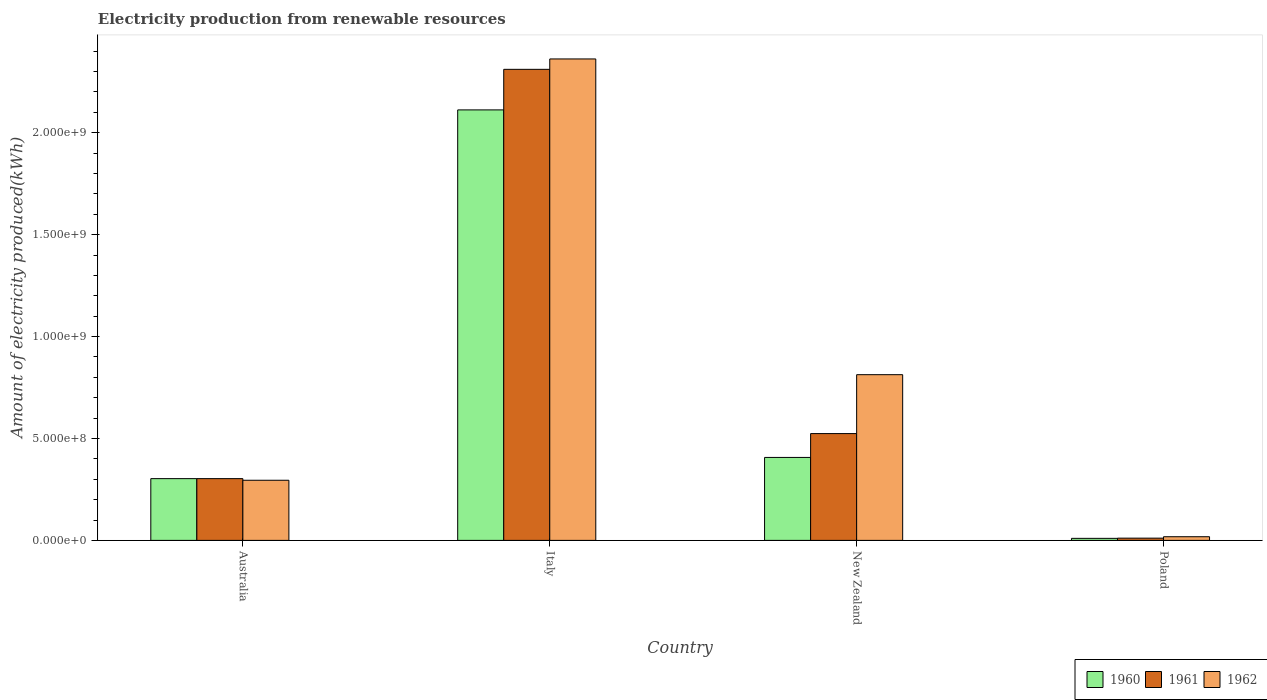How many different coloured bars are there?
Give a very brief answer. 3. How many groups of bars are there?
Keep it short and to the point. 4. Are the number of bars on each tick of the X-axis equal?
Provide a succinct answer. Yes. How many bars are there on the 4th tick from the left?
Make the answer very short. 3. How many bars are there on the 2nd tick from the right?
Keep it short and to the point. 3. What is the amount of electricity produced in 1961 in Poland?
Give a very brief answer. 1.10e+07. Across all countries, what is the maximum amount of electricity produced in 1961?
Provide a succinct answer. 2.31e+09. Across all countries, what is the minimum amount of electricity produced in 1962?
Offer a terse response. 1.80e+07. In which country was the amount of electricity produced in 1961 maximum?
Your response must be concise. Italy. In which country was the amount of electricity produced in 1960 minimum?
Ensure brevity in your answer.  Poland. What is the total amount of electricity produced in 1960 in the graph?
Provide a short and direct response. 2.83e+09. What is the difference between the amount of electricity produced in 1960 in Australia and that in Poland?
Make the answer very short. 2.93e+08. What is the difference between the amount of electricity produced in 1962 in Poland and the amount of electricity produced in 1961 in Italy?
Provide a succinct answer. -2.29e+09. What is the average amount of electricity produced in 1962 per country?
Your answer should be very brief. 8.72e+08. What is the difference between the amount of electricity produced of/in 1961 and amount of electricity produced of/in 1962 in New Zealand?
Offer a terse response. -2.89e+08. In how many countries, is the amount of electricity produced in 1961 greater than 300000000 kWh?
Make the answer very short. 3. What is the ratio of the amount of electricity produced in 1960 in New Zealand to that in Poland?
Offer a terse response. 40.7. Is the amount of electricity produced in 1961 in Australia less than that in Poland?
Your response must be concise. No. What is the difference between the highest and the second highest amount of electricity produced in 1960?
Your answer should be compact. 1.81e+09. What is the difference between the highest and the lowest amount of electricity produced in 1960?
Offer a terse response. 2.10e+09. In how many countries, is the amount of electricity produced in 1962 greater than the average amount of electricity produced in 1962 taken over all countries?
Give a very brief answer. 1. Is the sum of the amount of electricity produced in 1960 in Italy and Poland greater than the maximum amount of electricity produced in 1961 across all countries?
Offer a terse response. No. What does the 1st bar from the left in Australia represents?
Your response must be concise. 1960. Are all the bars in the graph horizontal?
Your answer should be compact. No. How many countries are there in the graph?
Your response must be concise. 4. What is the difference between two consecutive major ticks on the Y-axis?
Ensure brevity in your answer.  5.00e+08. Does the graph contain any zero values?
Provide a short and direct response. No. Does the graph contain grids?
Your answer should be very brief. No. How many legend labels are there?
Offer a very short reply. 3. How are the legend labels stacked?
Offer a terse response. Horizontal. What is the title of the graph?
Ensure brevity in your answer.  Electricity production from renewable resources. What is the label or title of the X-axis?
Provide a succinct answer. Country. What is the label or title of the Y-axis?
Offer a very short reply. Amount of electricity produced(kWh). What is the Amount of electricity produced(kWh) of 1960 in Australia?
Keep it short and to the point. 3.03e+08. What is the Amount of electricity produced(kWh) in 1961 in Australia?
Provide a short and direct response. 3.03e+08. What is the Amount of electricity produced(kWh) of 1962 in Australia?
Your answer should be very brief. 2.95e+08. What is the Amount of electricity produced(kWh) in 1960 in Italy?
Your response must be concise. 2.11e+09. What is the Amount of electricity produced(kWh) in 1961 in Italy?
Your answer should be compact. 2.31e+09. What is the Amount of electricity produced(kWh) in 1962 in Italy?
Provide a succinct answer. 2.36e+09. What is the Amount of electricity produced(kWh) in 1960 in New Zealand?
Provide a short and direct response. 4.07e+08. What is the Amount of electricity produced(kWh) in 1961 in New Zealand?
Your answer should be compact. 5.24e+08. What is the Amount of electricity produced(kWh) in 1962 in New Zealand?
Ensure brevity in your answer.  8.13e+08. What is the Amount of electricity produced(kWh) in 1961 in Poland?
Your response must be concise. 1.10e+07. What is the Amount of electricity produced(kWh) of 1962 in Poland?
Keep it short and to the point. 1.80e+07. Across all countries, what is the maximum Amount of electricity produced(kWh) in 1960?
Keep it short and to the point. 2.11e+09. Across all countries, what is the maximum Amount of electricity produced(kWh) of 1961?
Ensure brevity in your answer.  2.31e+09. Across all countries, what is the maximum Amount of electricity produced(kWh) in 1962?
Provide a short and direct response. 2.36e+09. Across all countries, what is the minimum Amount of electricity produced(kWh) in 1961?
Your answer should be very brief. 1.10e+07. Across all countries, what is the minimum Amount of electricity produced(kWh) of 1962?
Your answer should be compact. 1.80e+07. What is the total Amount of electricity produced(kWh) in 1960 in the graph?
Offer a very short reply. 2.83e+09. What is the total Amount of electricity produced(kWh) in 1961 in the graph?
Provide a succinct answer. 3.15e+09. What is the total Amount of electricity produced(kWh) in 1962 in the graph?
Provide a succinct answer. 3.49e+09. What is the difference between the Amount of electricity produced(kWh) of 1960 in Australia and that in Italy?
Offer a very short reply. -1.81e+09. What is the difference between the Amount of electricity produced(kWh) in 1961 in Australia and that in Italy?
Keep it short and to the point. -2.01e+09. What is the difference between the Amount of electricity produced(kWh) in 1962 in Australia and that in Italy?
Your answer should be compact. -2.07e+09. What is the difference between the Amount of electricity produced(kWh) in 1960 in Australia and that in New Zealand?
Offer a terse response. -1.04e+08. What is the difference between the Amount of electricity produced(kWh) in 1961 in Australia and that in New Zealand?
Make the answer very short. -2.21e+08. What is the difference between the Amount of electricity produced(kWh) in 1962 in Australia and that in New Zealand?
Your answer should be very brief. -5.18e+08. What is the difference between the Amount of electricity produced(kWh) of 1960 in Australia and that in Poland?
Provide a succinct answer. 2.93e+08. What is the difference between the Amount of electricity produced(kWh) of 1961 in Australia and that in Poland?
Provide a short and direct response. 2.92e+08. What is the difference between the Amount of electricity produced(kWh) in 1962 in Australia and that in Poland?
Offer a terse response. 2.77e+08. What is the difference between the Amount of electricity produced(kWh) of 1960 in Italy and that in New Zealand?
Make the answer very short. 1.70e+09. What is the difference between the Amount of electricity produced(kWh) in 1961 in Italy and that in New Zealand?
Keep it short and to the point. 1.79e+09. What is the difference between the Amount of electricity produced(kWh) in 1962 in Italy and that in New Zealand?
Give a very brief answer. 1.55e+09. What is the difference between the Amount of electricity produced(kWh) of 1960 in Italy and that in Poland?
Provide a succinct answer. 2.10e+09. What is the difference between the Amount of electricity produced(kWh) of 1961 in Italy and that in Poland?
Your answer should be very brief. 2.30e+09. What is the difference between the Amount of electricity produced(kWh) in 1962 in Italy and that in Poland?
Offer a terse response. 2.34e+09. What is the difference between the Amount of electricity produced(kWh) of 1960 in New Zealand and that in Poland?
Ensure brevity in your answer.  3.97e+08. What is the difference between the Amount of electricity produced(kWh) of 1961 in New Zealand and that in Poland?
Your answer should be very brief. 5.13e+08. What is the difference between the Amount of electricity produced(kWh) in 1962 in New Zealand and that in Poland?
Provide a short and direct response. 7.95e+08. What is the difference between the Amount of electricity produced(kWh) of 1960 in Australia and the Amount of electricity produced(kWh) of 1961 in Italy?
Offer a very short reply. -2.01e+09. What is the difference between the Amount of electricity produced(kWh) of 1960 in Australia and the Amount of electricity produced(kWh) of 1962 in Italy?
Provide a short and direct response. -2.06e+09. What is the difference between the Amount of electricity produced(kWh) of 1961 in Australia and the Amount of electricity produced(kWh) of 1962 in Italy?
Keep it short and to the point. -2.06e+09. What is the difference between the Amount of electricity produced(kWh) of 1960 in Australia and the Amount of electricity produced(kWh) of 1961 in New Zealand?
Provide a succinct answer. -2.21e+08. What is the difference between the Amount of electricity produced(kWh) of 1960 in Australia and the Amount of electricity produced(kWh) of 1962 in New Zealand?
Give a very brief answer. -5.10e+08. What is the difference between the Amount of electricity produced(kWh) of 1961 in Australia and the Amount of electricity produced(kWh) of 1962 in New Zealand?
Provide a succinct answer. -5.10e+08. What is the difference between the Amount of electricity produced(kWh) in 1960 in Australia and the Amount of electricity produced(kWh) in 1961 in Poland?
Your response must be concise. 2.92e+08. What is the difference between the Amount of electricity produced(kWh) in 1960 in Australia and the Amount of electricity produced(kWh) in 1962 in Poland?
Make the answer very short. 2.85e+08. What is the difference between the Amount of electricity produced(kWh) in 1961 in Australia and the Amount of electricity produced(kWh) in 1962 in Poland?
Offer a very short reply. 2.85e+08. What is the difference between the Amount of electricity produced(kWh) in 1960 in Italy and the Amount of electricity produced(kWh) in 1961 in New Zealand?
Your answer should be very brief. 1.59e+09. What is the difference between the Amount of electricity produced(kWh) in 1960 in Italy and the Amount of electricity produced(kWh) in 1962 in New Zealand?
Ensure brevity in your answer.  1.30e+09. What is the difference between the Amount of electricity produced(kWh) in 1961 in Italy and the Amount of electricity produced(kWh) in 1962 in New Zealand?
Your answer should be very brief. 1.50e+09. What is the difference between the Amount of electricity produced(kWh) in 1960 in Italy and the Amount of electricity produced(kWh) in 1961 in Poland?
Your answer should be compact. 2.10e+09. What is the difference between the Amount of electricity produced(kWh) of 1960 in Italy and the Amount of electricity produced(kWh) of 1962 in Poland?
Offer a terse response. 2.09e+09. What is the difference between the Amount of electricity produced(kWh) in 1961 in Italy and the Amount of electricity produced(kWh) in 1962 in Poland?
Offer a terse response. 2.29e+09. What is the difference between the Amount of electricity produced(kWh) in 1960 in New Zealand and the Amount of electricity produced(kWh) in 1961 in Poland?
Provide a succinct answer. 3.96e+08. What is the difference between the Amount of electricity produced(kWh) of 1960 in New Zealand and the Amount of electricity produced(kWh) of 1962 in Poland?
Your answer should be very brief. 3.89e+08. What is the difference between the Amount of electricity produced(kWh) of 1961 in New Zealand and the Amount of electricity produced(kWh) of 1962 in Poland?
Your response must be concise. 5.06e+08. What is the average Amount of electricity produced(kWh) of 1960 per country?
Your answer should be compact. 7.08e+08. What is the average Amount of electricity produced(kWh) of 1961 per country?
Offer a very short reply. 7.87e+08. What is the average Amount of electricity produced(kWh) in 1962 per country?
Provide a succinct answer. 8.72e+08. What is the difference between the Amount of electricity produced(kWh) in 1960 and Amount of electricity produced(kWh) in 1961 in Australia?
Provide a succinct answer. 0. What is the difference between the Amount of electricity produced(kWh) of 1960 and Amount of electricity produced(kWh) of 1962 in Australia?
Make the answer very short. 8.00e+06. What is the difference between the Amount of electricity produced(kWh) in 1960 and Amount of electricity produced(kWh) in 1961 in Italy?
Your answer should be very brief. -1.99e+08. What is the difference between the Amount of electricity produced(kWh) of 1960 and Amount of electricity produced(kWh) of 1962 in Italy?
Your answer should be very brief. -2.50e+08. What is the difference between the Amount of electricity produced(kWh) in 1961 and Amount of electricity produced(kWh) in 1962 in Italy?
Your answer should be very brief. -5.10e+07. What is the difference between the Amount of electricity produced(kWh) of 1960 and Amount of electricity produced(kWh) of 1961 in New Zealand?
Give a very brief answer. -1.17e+08. What is the difference between the Amount of electricity produced(kWh) in 1960 and Amount of electricity produced(kWh) in 1962 in New Zealand?
Make the answer very short. -4.06e+08. What is the difference between the Amount of electricity produced(kWh) of 1961 and Amount of electricity produced(kWh) of 1962 in New Zealand?
Offer a terse response. -2.89e+08. What is the difference between the Amount of electricity produced(kWh) in 1960 and Amount of electricity produced(kWh) in 1962 in Poland?
Provide a succinct answer. -8.00e+06. What is the difference between the Amount of electricity produced(kWh) in 1961 and Amount of electricity produced(kWh) in 1962 in Poland?
Make the answer very short. -7.00e+06. What is the ratio of the Amount of electricity produced(kWh) in 1960 in Australia to that in Italy?
Your answer should be very brief. 0.14. What is the ratio of the Amount of electricity produced(kWh) of 1961 in Australia to that in Italy?
Your response must be concise. 0.13. What is the ratio of the Amount of electricity produced(kWh) of 1962 in Australia to that in Italy?
Your answer should be very brief. 0.12. What is the ratio of the Amount of electricity produced(kWh) of 1960 in Australia to that in New Zealand?
Keep it short and to the point. 0.74. What is the ratio of the Amount of electricity produced(kWh) of 1961 in Australia to that in New Zealand?
Give a very brief answer. 0.58. What is the ratio of the Amount of electricity produced(kWh) in 1962 in Australia to that in New Zealand?
Provide a short and direct response. 0.36. What is the ratio of the Amount of electricity produced(kWh) of 1960 in Australia to that in Poland?
Provide a short and direct response. 30.3. What is the ratio of the Amount of electricity produced(kWh) of 1961 in Australia to that in Poland?
Your answer should be compact. 27.55. What is the ratio of the Amount of electricity produced(kWh) in 1962 in Australia to that in Poland?
Your answer should be very brief. 16.39. What is the ratio of the Amount of electricity produced(kWh) in 1960 in Italy to that in New Zealand?
Provide a short and direct response. 5.19. What is the ratio of the Amount of electricity produced(kWh) in 1961 in Italy to that in New Zealand?
Give a very brief answer. 4.41. What is the ratio of the Amount of electricity produced(kWh) of 1962 in Italy to that in New Zealand?
Make the answer very short. 2.91. What is the ratio of the Amount of electricity produced(kWh) of 1960 in Italy to that in Poland?
Keep it short and to the point. 211.2. What is the ratio of the Amount of electricity produced(kWh) of 1961 in Italy to that in Poland?
Ensure brevity in your answer.  210.09. What is the ratio of the Amount of electricity produced(kWh) of 1962 in Italy to that in Poland?
Make the answer very short. 131.22. What is the ratio of the Amount of electricity produced(kWh) in 1960 in New Zealand to that in Poland?
Make the answer very short. 40.7. What is the ratio of the Amount of electricity produced(kWh) of 1961 in New Zealand to that in Poland?
Keep it short and to the point. 47.64. What is the ratio of the Amount of electricity produced(kWh) of 1962 in New Zealand to that in Poland?
Ensure brevity in your answer.  45.17. What is the difference between the highest and the second highest Amount of electricity produced(kWh) of 1960?
Your answer should be compact. 1.70e+09. What is the difference between the highest and the second highest Amount of electricity produced(kWh) in 1961?
Provide a short and direct response. 1.79e+09. What is the difference between the highest and the second highest Amount of electricity produced(kWh) of 1962?
Your answer should be compact. 1.55e+09. What is the difference between the highest and the lowest Amount of electricity produced(kWh) of 1960?
Ensure brevity in your answer.  2.10e+09. What is the difference between the highest and the lowest Amount of electricity produced(kWh) of 1961?
Offer a very short reply. 2.30e+09. What is the difference between the highest and the lowest Amount of electricity produced(kWh) of 1962?
Provide a succinct answer. 2.34e+09. 